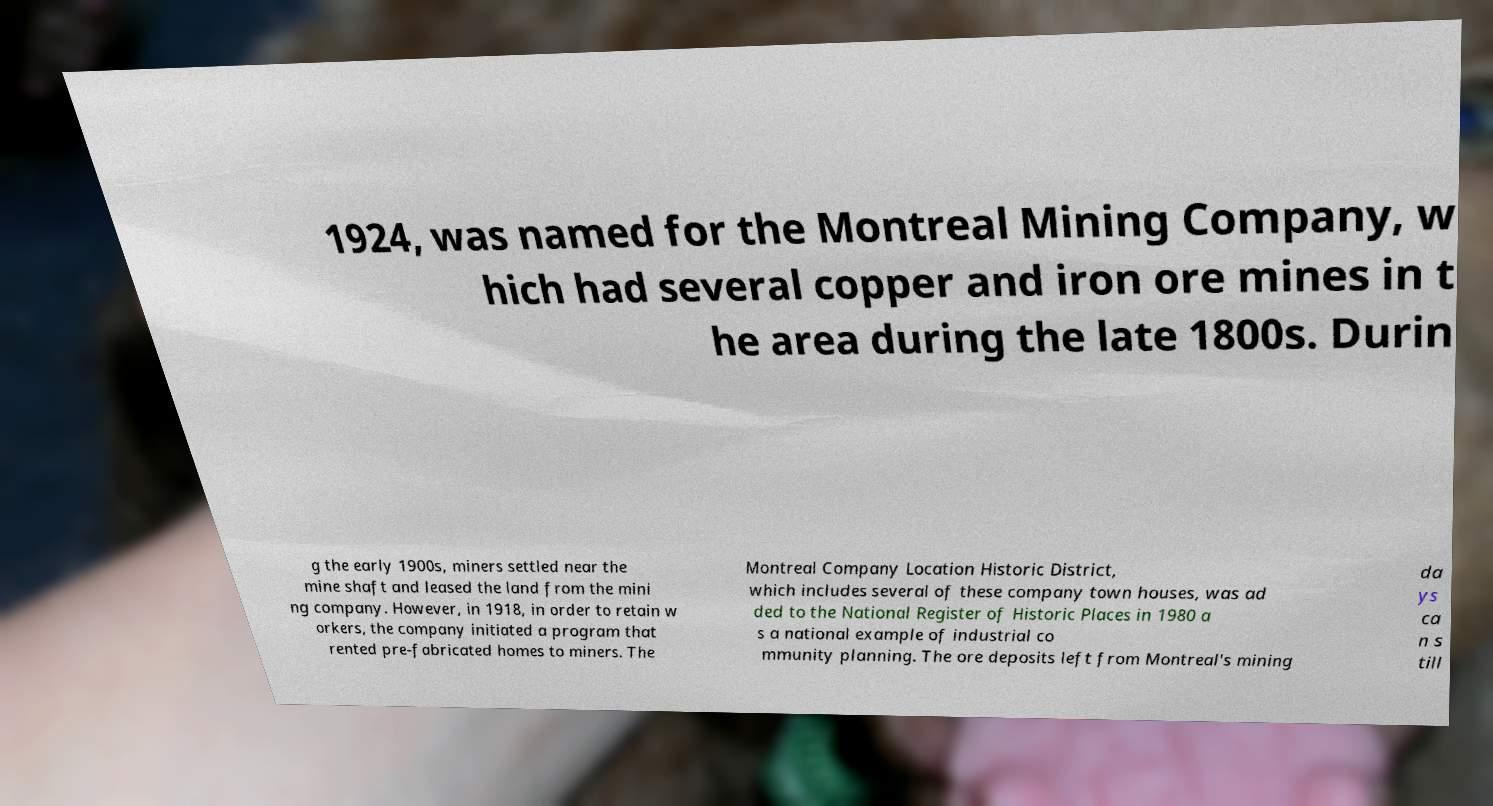What messages or text are displayed in this image? I need them in a readable, typed format. 1924, was named for the Montreal Mining Company, w hich had several copper and iron ore mines in t he area during the late 1800s. Durin g the early 1900s, miners settled near the mine shaft and leased the land from the mini ng company. However, in 1918, in order to retain w orkers, the company initiated a program that rented pre-fabricated homes to miners. The Montreal Company Location Historic District, which includes several of these company town houses, was ad ded to the National Register of Historic Places in 1980 a s a national example of industrial co mmunity planning. The ore deposits left from Montreal's mining da ys ca n s till 